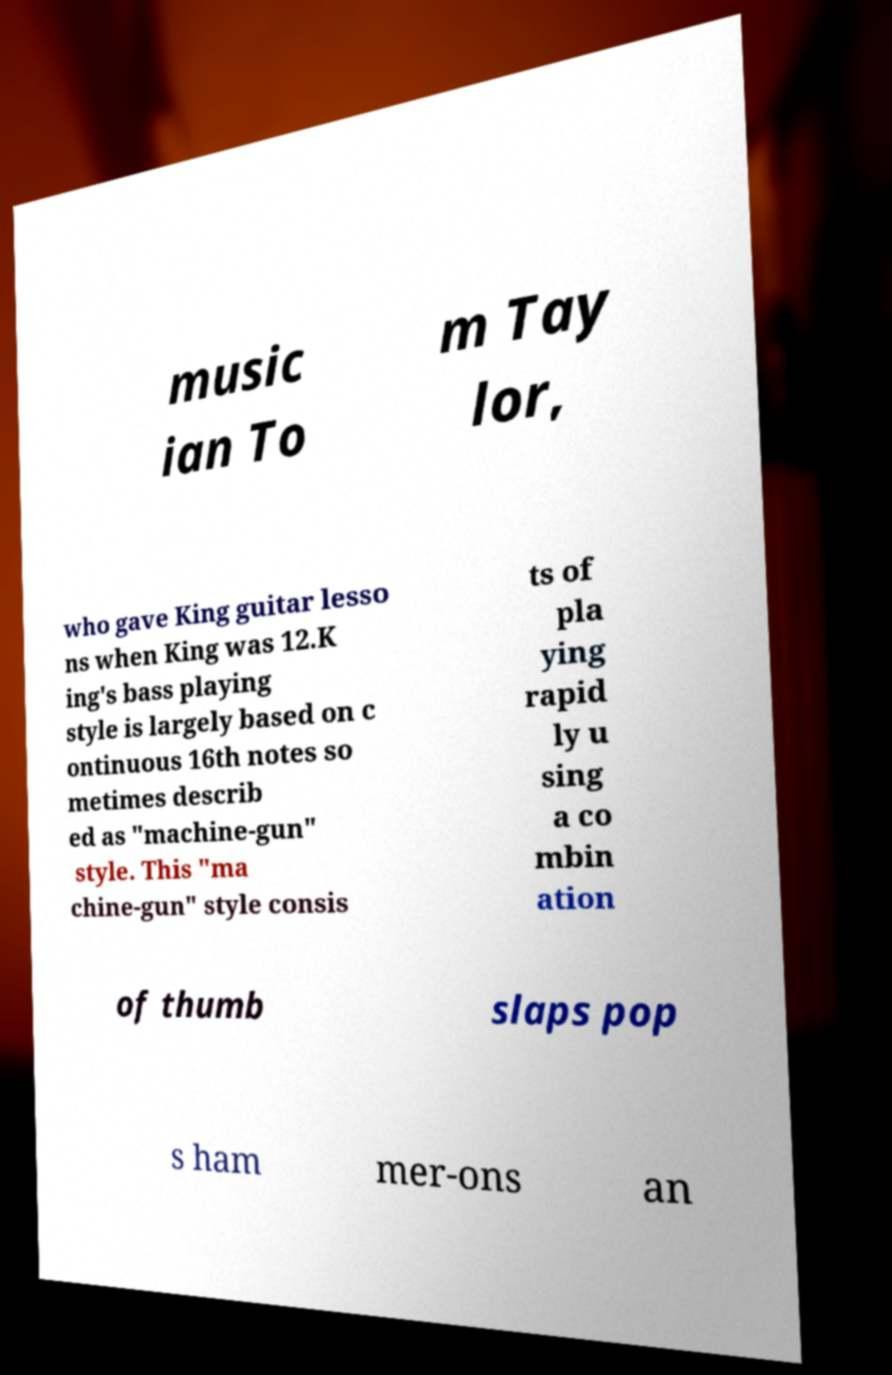Please identify and transcribe the text found in this image. music ian To m Tay lor, who gave King guitar lesso ns when King was 12.K ing's bass playing style is largely based on c ontinuous 16th notes so metimes describ ed as "machine-gun" style. This "ma chine-gun" style consis ts of pla ying rapid ly u sing a co mbin ation of thumb slaps pop s ham mer-ons an 